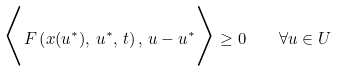<formula> <loc_0><loc_0><loc_500><loc_500>\Big < F \left ( x ( u ^ { * } ) , \, u ^ { * } , \, t \right ) , \, u - u ^ { * } \Big > \geq 0 \quad \forall u \in U</formula> 